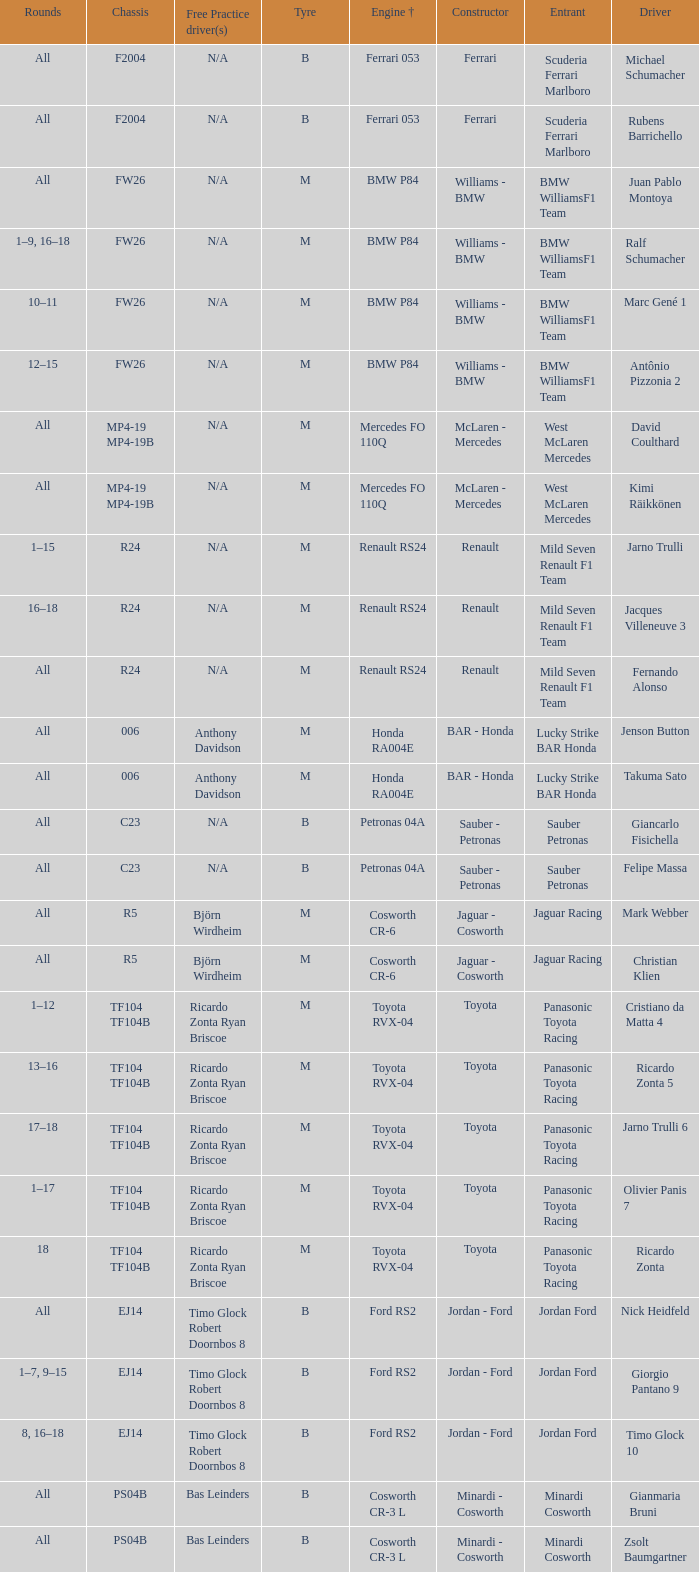What are the rounds for the B tyres and Ferrari 053 engine +? All, All. 